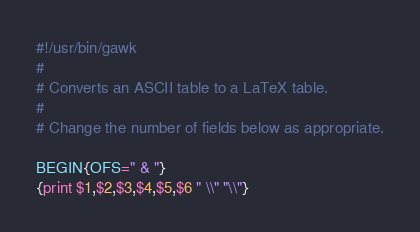Convert code to text. <code><loc_0><loc_0><loc_500><loc_500><_Awk_>#!/usr/bin/gawk
#
# Converts an ASCII table to a LaTeX table.
#
# Change the number of fields below as appropriate.

BEGIN{OFS=" & "}
{print $1,$2,$3,$4,$5,$6 " \\" "\\"}</code> 